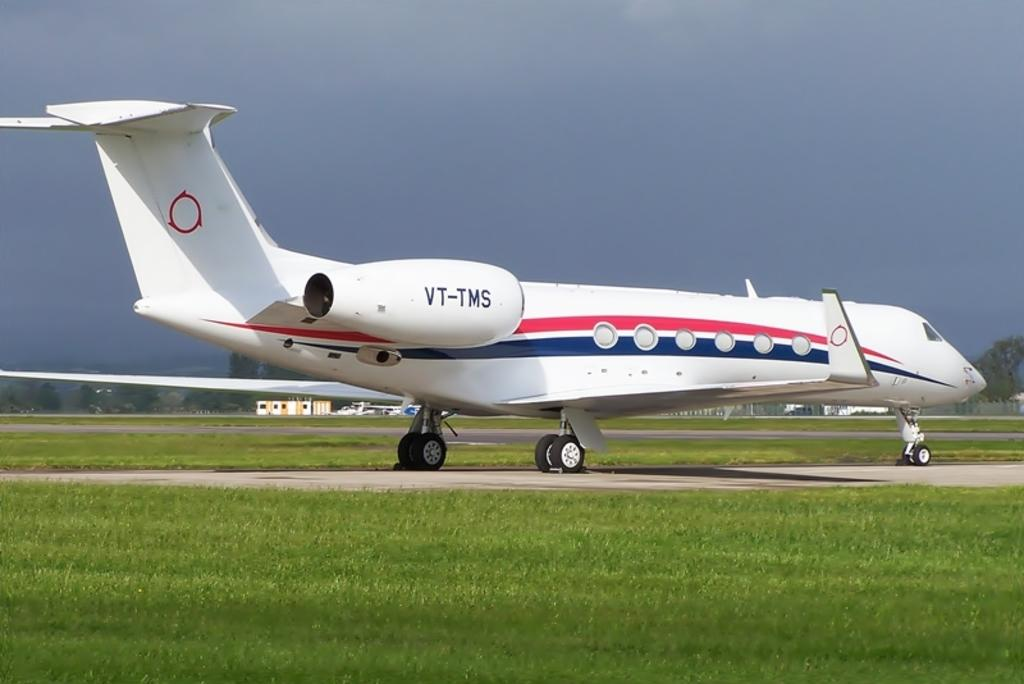<image>
Summarize the visual content of the image. A white plane is on a runway with VT-TMS on the tail end. 